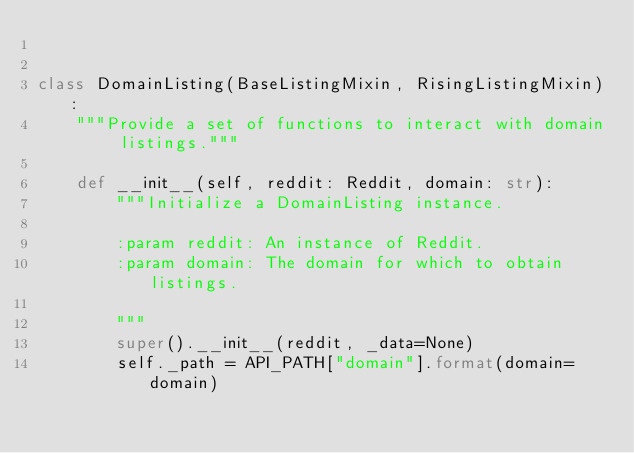<code> <loc_0><loc_0><loc_500><loc_500><_Python_>

class DomainListing(BaseListingMixin, RisingListingMixin):
    """Provide a set of functions to interact with domain listings."""

    def __init__(self, reddit: Reddit, domain: str):
        """Initialize a DomainListing instance.

        :param reddit: An instance of Reddit.
        :param domain: The domain for which to obtain listings.

        """
        super().__init__(reddit, _data=None)
        self._path = API_PATH["domain"].format(domain=domain)
</code> 